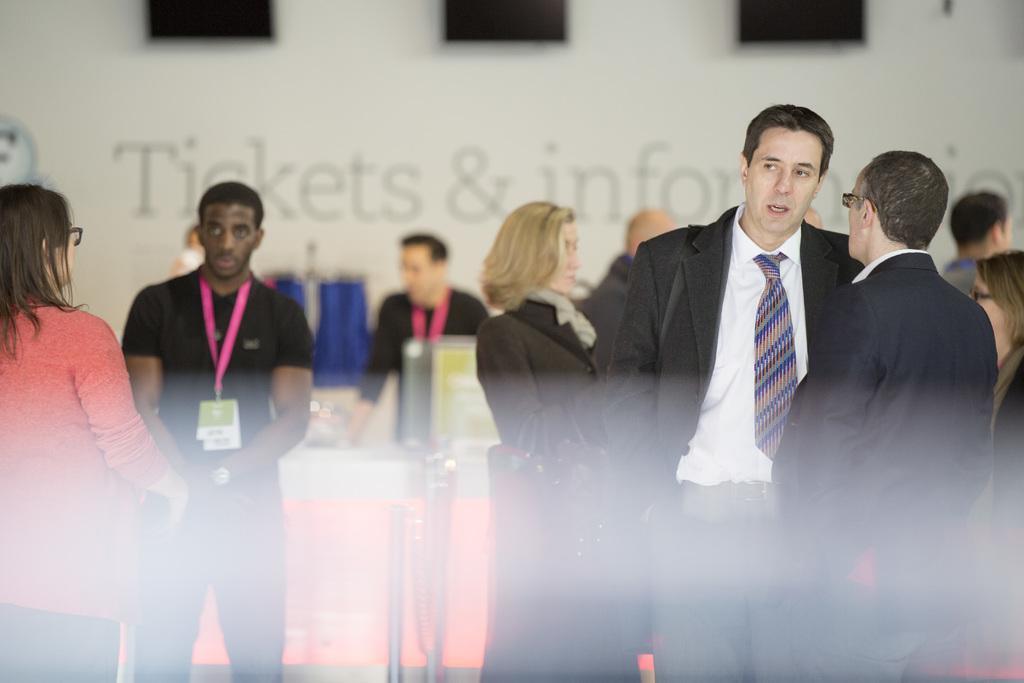Describe this image in one or two sentences. This image consists many people. In the front, we can see two men wearing black suits are talking. On the left, we can see a woman wearing a pink shirt. Beside her, there is a man wearing a black T-shirt along with a tag. In the background, we can see a wall. In the middle, there are metal rods. And we can see a table in the middle. 